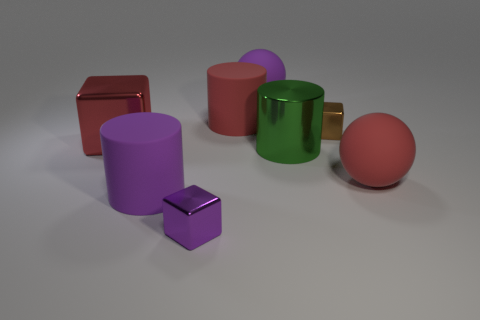What shape is the red thing that is made of the same material as the large red cylinder?
Ensure brevity in your answer.  Sphere. What number of red things are either large shiny cylinders or spheres?
Your answer should be very brief. 1. There is a green object; are there any red objects to the left of it?
Provide a short and direct response. Yes. There is a large purple thing to the left of the tiny purple metallic block; is it the same shape as the red matte object that is on the left side of the big red sphere?
Keep it short and to the point. Yes. There is a large red object that is the same shape as the green thing; what material is it?
Provide a short and direct response. Rubber. How many cubes are either red things or big red rubber things?
Offer a terse response. 1. What number of red balls are made of the same material as the large red block?
Provide a succinct answer. 0. Is the small cube behind the tiny purple object made of the same material as the ball that is to the left of the metal cylinder?
Make the answer very short. No. There is a big sphere that is in front of the purple thing behind the red metal cube; what number of tiny shiny cubes are behind it?
Your response must be concise. 1. Does the large rubber cylinder that is left of the red cylinder have the same color as the rubber sphere that is on the left side of the metallic cylinder?
Keep it short and to the point. Yes. 